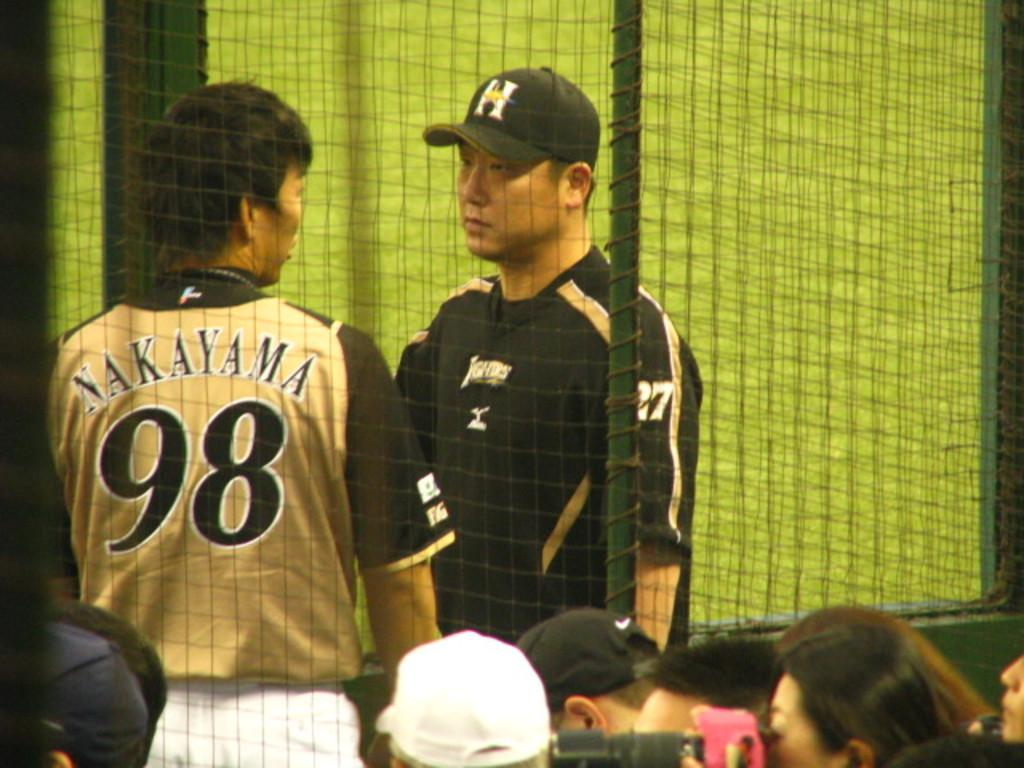<image>
Present a compact description of the photo's key features. Number 98 and number 27 talk in front of the fans. 